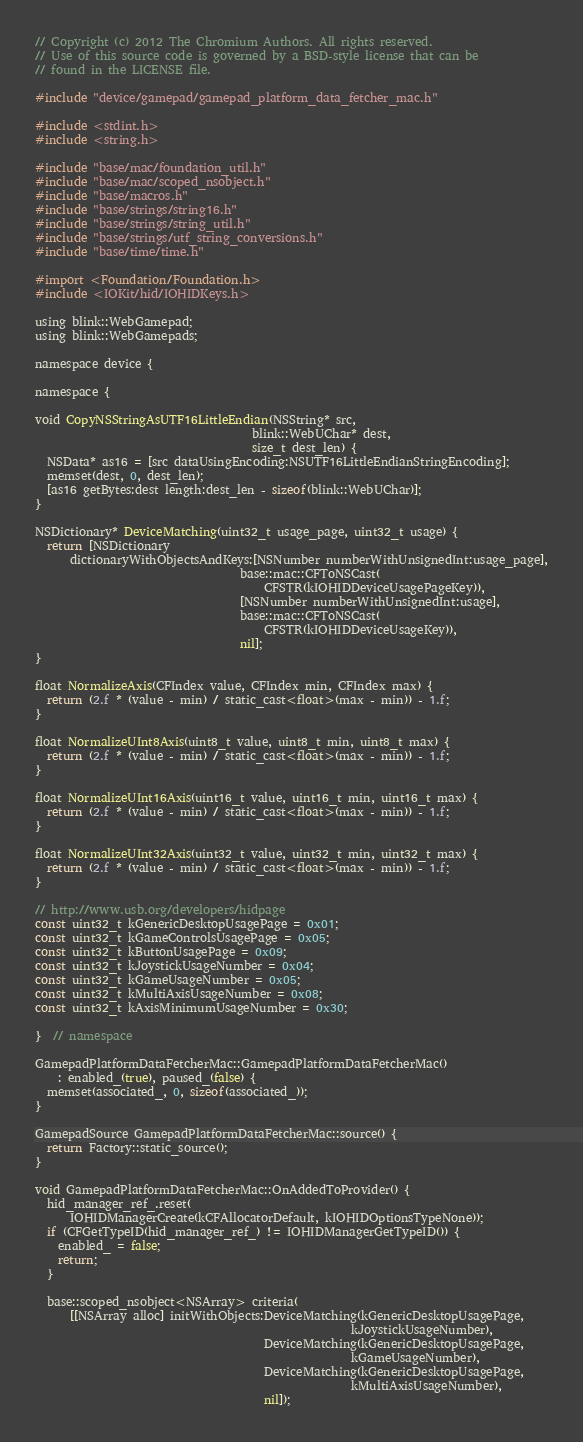<code> <loc_0><loc_0><loc_500><loc_500><_ObjectiveC_>// Copyright (c) 2012 The Chromium Authors. All rights reserved.
// Use of this source code is governed by a BSD-style license that can be
// found in the LICENSE file.

#include "device/gamepad/gamepad_platform_data_fetcher_mac.h"

#include <stdint.h>
#include <string.h>

#include "base/mac/foundation_util.h"
#include "base/mac/scoped_nsobject.h"
#include "base/macros.h"
#include "base/strings/string16.h"
#include "base/strings/string_util.h"
#include "base/strings/utf_string_conversions.h"
#include "base/time/time.h"

#import <Foundation/Foundation.h>
#include <IOKit/hid/IOHIDKeys.h>

using blink::WebGamepad;
using blink::WebGamepads;

namespace device {

namespace {

void CopyNSStringAsUTF16LittleEndian(NSString* src,
                                     blink::WebUChar* dest,
                                     size_t dest_len) {
  NSData* as16 = [src dataUsingEncoding:NSUTF16LittleEndianStringEncoding];
  memset(dest, 0, dest_len);
  [as16 getBytes:dest length:dest_len - sizeof(blink::WebUChar)];
}

NSDictionary* DeviceMatching(uint32_t usage_page, uint32_t usage) {
  return [NSDictionary
      dictionaryWithObjectsAndKeys:[NSNumber numberWithUnsignedInt:usage_page],
                                   base::mac::CFToNSCast(
                                       CFSTR(kIOHIDDeviceUsagePageKey)),
                                   [NSNumber numberWithUnsignedInt:usage],
                                   base::mac::CFToNSCast(
                                       CFSTR(kIOHIDDeviceUsageKey)),
                                   nil];
}

float NormalizeAxis(CFIndex value, CFIndex min, CFIndex max) {
  return (2.f * (value - min) / static_cast<float>(max - min)) - 1.f;
}

float NormalizeUInt8Axis(uint8_t value, uint8_t min, uint8_t max) {
  return (2.f * (value - min) / static_cast<float>(max - min)) - 1.f;
}

float NormalizeUInt16Axis(uint16_t value, uint16_t min, uint16_t max) {
  return (2.f * (value - min) / static_cast<float>(max - min)) - 1.f;
}

float NormalizeUInt32Axis(uint32_t value, uint32_t min, uint32_t max) {
  return (2.f * (value - min) / static_cast<float>(max - min)) - 1.f;
}

// http://www.usb.org/developers/hidpage
const uint32_t kGenericDesktopUsagePage = 0x01;
const uint32_t kGameControlsUsagePage = 0x05;
const uint32_t kButtonUsagePage = 0x09;
const uint32_t kJoystickUsageNumber = 0x04;
const uint32_t kGameUsageNumber = 0x05;
const uint32_t kMultiAxisUsageNumber = 0x08;
const uint32_t kAxisMinimumUsageNumber = 0x30;

}  // namespace

GamepadPlatformDataFetcherMac::GamepadPlatformDataFetcherMac()
    : enabled_(true), paused_(false) {
  memset(associated_, 0, sizeof(associated_));
}

GamepadSource GamepadPlatformDataFetcherMac::source() {
  return Factory::static_source();
}

void GamepadPlatformDataFetcherMac::OnAddedToProvider() {
  hid_manager_ref_.reset(
      IOHIDManagerCreate(kCFAllocatorDefault, kIOHIDOptionsTypeNone));
  if (CFGetTypeID(hid_manager_ref_) != IOHIDManagerGetTypeID()) {
    enabled_ = false;
    return;
  }

  base::scoped_nsobject<NSArray> criteria(
      [[NSArray alloc] initWithObjects:DeviceMatching(kGenericDesktopUsagePage,
                                                      kJoystickUsageNumber),
                                       DeviceMatching(kGenericDesktopUsagePage,
                                                      kGameUsageNumber),
                                       DeviceMatching(kGenericDesktopUsagePage,
                                                      kMultiAxisUsageNumber),
                                       nil]);</code> 